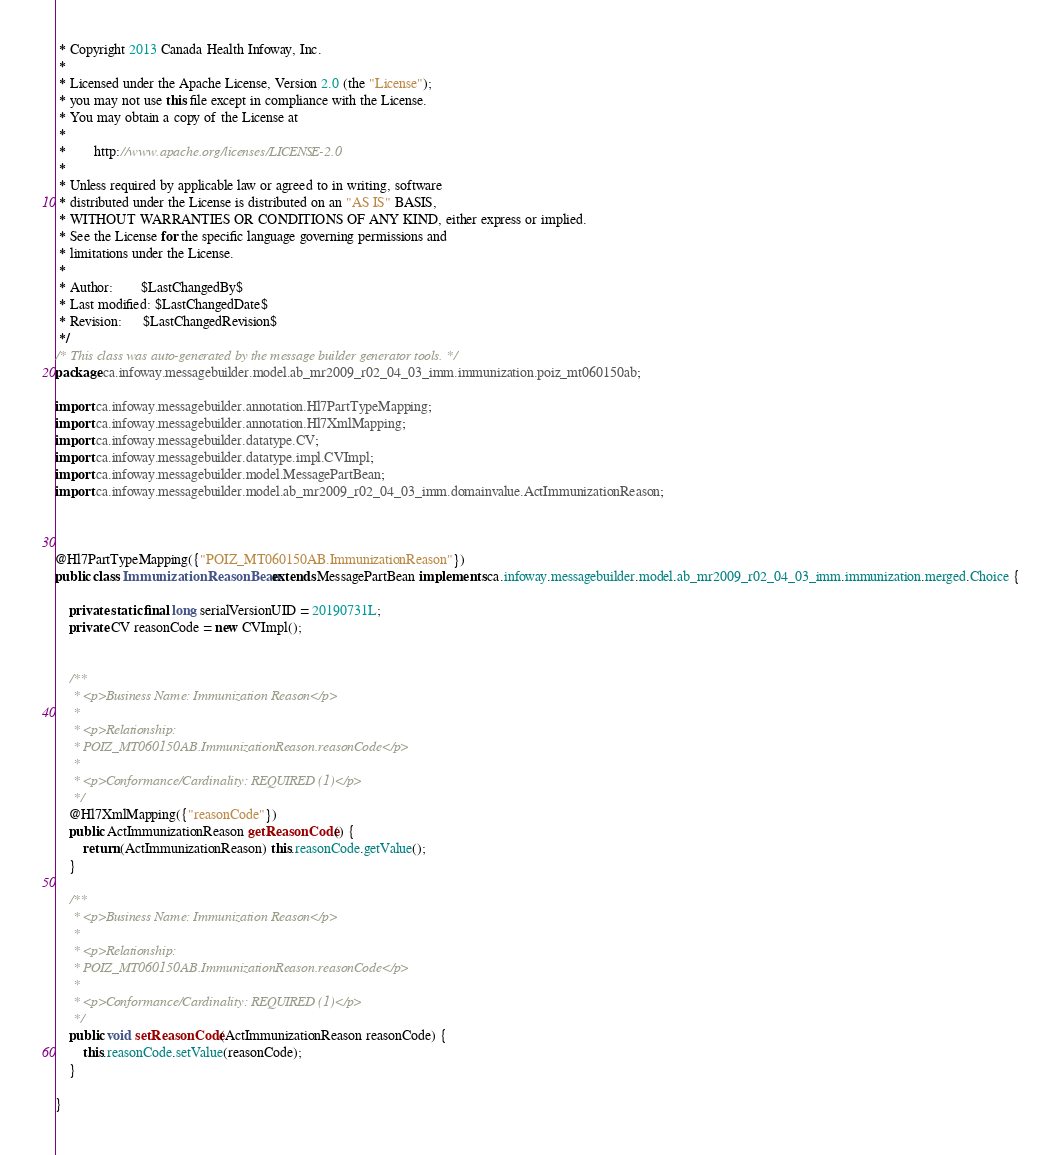<code> <loc_0><loc_0><loc_500><loc_500><_Java_> * Copyright 2013 Canada Health Infoway, Inc.
 *
 * Licensed under the Apache License, Version 2.0 (the "License");
 * you may not use this file except in compliance with the License.
 * You may obtain a copy of the License at
 *
 *        http://www.apache.org/licenses/LICENSE-2.0
 *
 * Unless required by applicable law or agreed to in writing, software
 * distributed under the License is distributed on an "AS IS" BASIS,
 * WITHOUT WARRANTIES OR CONDITIONS OF ANY KIND, either express or implied.
 * See the License for the specific language governing permissions and
 * limitations under the License.
 *
 * Author:        $LastChangedBy$
 * Last modified: $LastChangedDate$
 * Revision:      $LastChangedRevision$
 */
/* This class was auto-generated by the message builder generator tools. */
package ca.infoway.messagebuilder.model.ab_mr2009_r02_04_03_imm.immunization.poiz_mt060150ab;

import ca.infoway.messagebuilder.annotation.Hl7PartTypeMapping;
import ca.infoway.messagebuilder.annotation.Hl7XmlMapping;
import ca.infoway.messagebuilder.datatype.CV;
import ca.infoway.messagebuilder.datatype.impl.CVImpl;
import ca.infoway.messagebuilder.model.MessagePartBean;
import ca.infoway.messagebuilder.model.ab_mr2009_r02_04_03_imm.domainvalue.ActImmunizationReason;



@Hl7PartTypeMapping({"POIZ_MT060150AB.ImmunizationReason"})
public class ImmunizationReasonBean extends MessagePartBean implements ca.infoway.messagebuilder.model.ab_mr2009_r02_04_03_imm.immunization.merged.Choice {

    private static final long serialVersionUID = 20190731L;
    private CV reasonCode = new CVImpl();


    /**
     * <p>Business Name: Immunization Reason</p>
     * 
     * <p>Relationship: 
     * POIZ_MT060150AB.ImmunizationReason.reasonCode</p>
     * 
     * <p>Conformance/Cardinality: REQUIRED (1)</p>
     */
    @Hl7XmlMapping({"reasonCode"})
    public ActImmunizationReason getReasonCode() {
        return (ActImmunizationReason) this.reasonCode.getValue();
    }

    /**
     * <p>Business Name: Immunization Reason</p>
     * 
     * <p>Relationship: 
     * POIZ_MT060150AB.ImmunizationReason.reasonCode</p>
     * 
     * <p>Conformance/Cardinality: REQUIRED (1)</p>
     */
    public void setReasonCode(ActImmunizationReason reasonCode) {
        this.reasonCode.setValue(reasonCode);
    }

}
</code> 